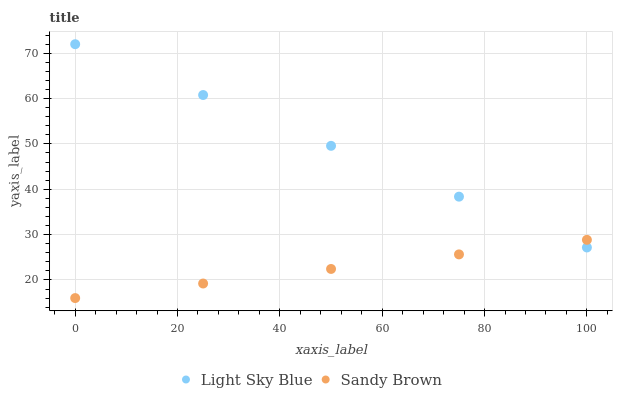Does Sandy Brown have the minimum area under the curve?
Answer yes or no. Yes. Does Light Sky Blue have the maximum area under the curve?
Answer yes or no. Yes. Does Sandy Brown have the maximum area under the curve?
Answer yes or no. No. Is Sandy Brown the smoothest?
Answer yes or no. Yes. Is Light Sky Blue the roughest?
Answer yes or no. Yes. Is Sandy Brown the roughest?
Answer yes or no. No. Does Sandy Brown have the lowest value?
Answer yes or no. Yes. Does Light Sky Blue have the highest value?
Answer yes or no. Yes. Does Sandy Brown have the highest value?
Answer yes or no. No. Does Light Sky Blue intersect Sandy Brown?
Answer yes or no. Yes. Is Light Sky Blue less than Sandy Brown?
Answer yes or no. No. Is Light Sky Blue greater than Sandy Brown?
Answer yes or no. No. 